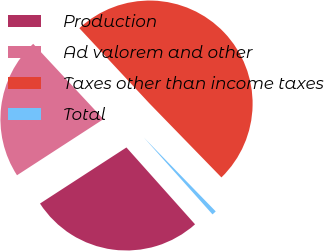Convert chart. <chart><loc_0><loc_0><loc_500><loc_500><pie_chart><fcel>Production<fcel>Ad valorem and other<fcel>Taxes other than income taxes<fcel>Total<nl><fcel>27.44%<fcel>22.22%<fcel>49.66%<fcel>0.68%<nl></chart> 